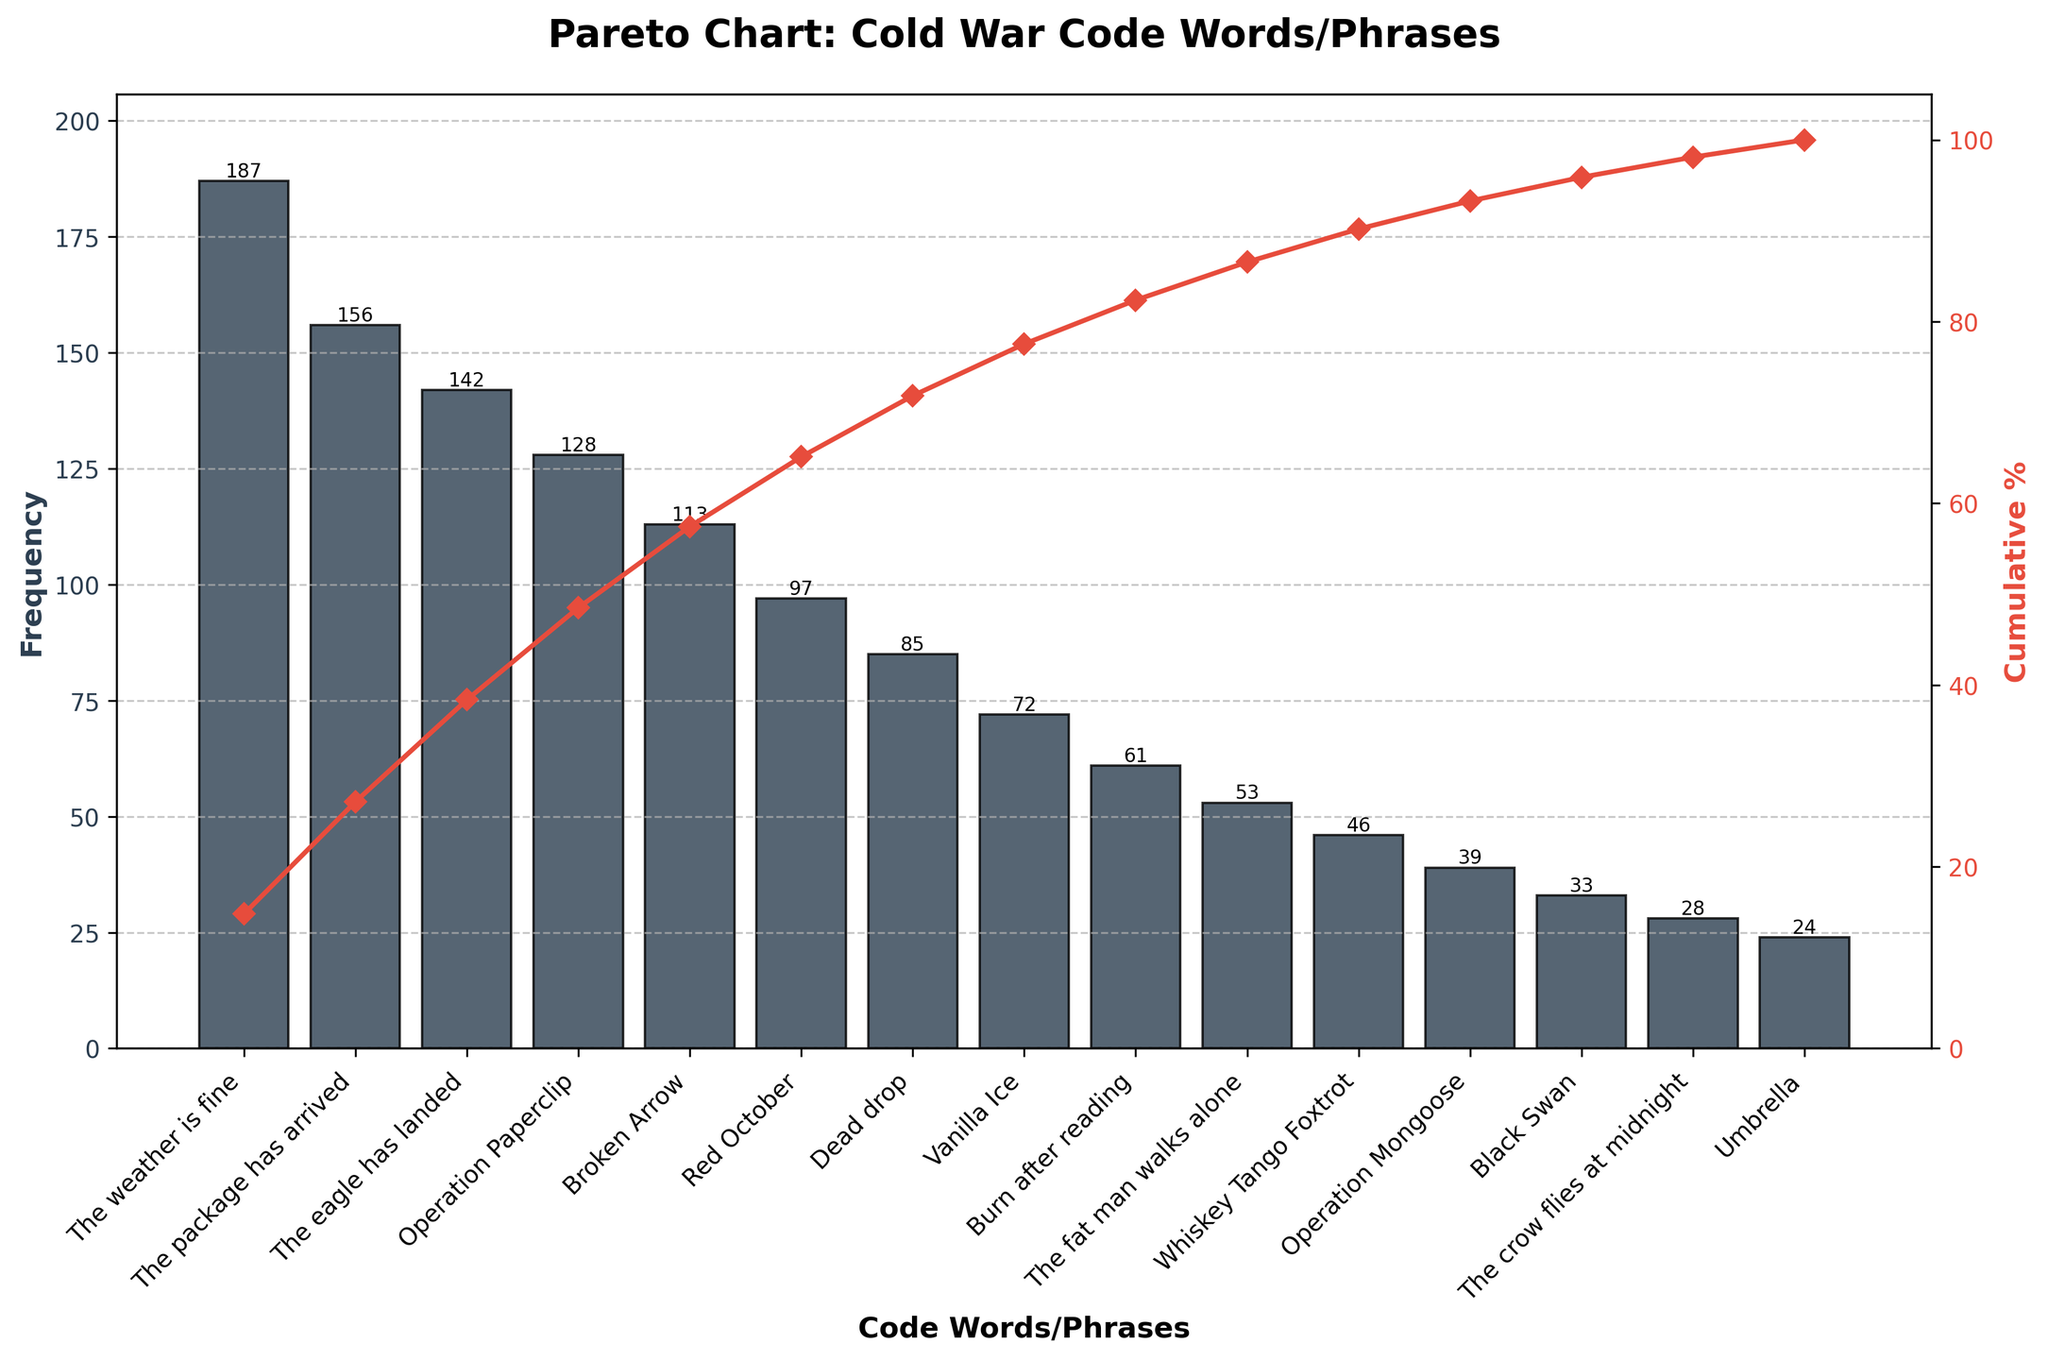What is the title of the figure? The title can be found at the top of the figure and it typically summarizes the main subject of the visualization. Here, the title reads "Pareto Chart: Cold War Code Words/Phrases".
Answer: Pareto Chart: Cold War Code Words/Phrases Which code word or phrase has the highest frequency? By looking at the heights of the bars in the bar chart, the tallest bar represents the most frequent code word or phrase. The label at the bottom of this bar is "The weather is fine".
Answer: The weather is fine What is the frequency of "The eagle has landed"? Locate the bar labeled "The eagle has landed" on the x-axis and read the corresponding height on the y-axis for frequency. Here, "The eagle has landed" corresponds to a frequency of 142.
Answer: 142 What percentage of the total frequency is contributed by the top three code words/phrases? First, identify the top three code words/phrases and their frequencies: "The weather is fine" (187), "The package has arrived" (156), "The eagle has landed" (142). Sum their frequencies: 187 + 156 + 142 = 485. Find the total frequency (sum of all frequencies): 1286. Calculate the percentage: (485 / 1286) * 100 ≈ 37.7%.
Answer: 37.7% Between "Operation Mongoose" and "Black Swan", which one has a higher frequency, and by how much? Compare the heights of the bars for "Operation Mongoose" and "Black Swan". "Operation Mongoose" has a frequency of 39, and "Black Swan" has 33. Subtract the smaller frequency from the larger one: 39 - 33 = 6.
Answer: Operation Mongoose by 6 How many code words/phrases have a frequency higher than 100? Identify and count the bars with heights above the 100 mark on the y-axis. These are: "The weather is fine", "The package has arrived", "The eagle has landed", and "Operation Paperclip". There are 4 such code words/phrases.
Answer: 4 What is the cumulative percentage when "Operation Paperclip" is included? Locate "Operation Paperclip" on the x-axis, and read the corresponding point on the cumulative percentage line, which is close to 50%.
Answer: 50% What is the height of the bar for "Red October"? Locate the "Red October" bar on the x-axis and read the height on the y-axis, which corresponds to a frequency of 97.
Answer: 97 